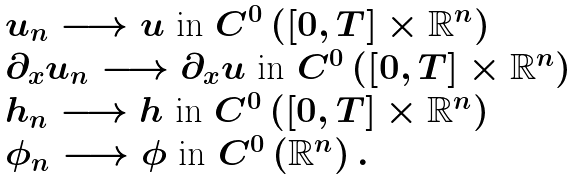<formula> <loc_0><loc_0><loc_500><loc_500>\begin{array} { l } u _ { n } \longrightarrow u \text { in } C ^ { 0 } \left ( \left [ 0 , T \right ] \times \mathbb { R } ^ { n } \right ) \\ \partial _ { x } u _ { n } \longrightarrow \partial _ { x } u \text { in } C ^ { 0 } \left ( \left [ 0 , T \right ] \times \mathbb { R } ^ { n } \right ) \\ h _ { n } \longrightarrow h \text { in } C ^ { 0 } \left ( \left [ 0 , T \right ] \times \mathbb { R } ^ { n } \right ) \\ \phi _ { n } \longrightarrow \phi \text { in } C ^ { 0 } \left ( \mathbb { R } ^ { n } \right ) . \end{array}</formula> 